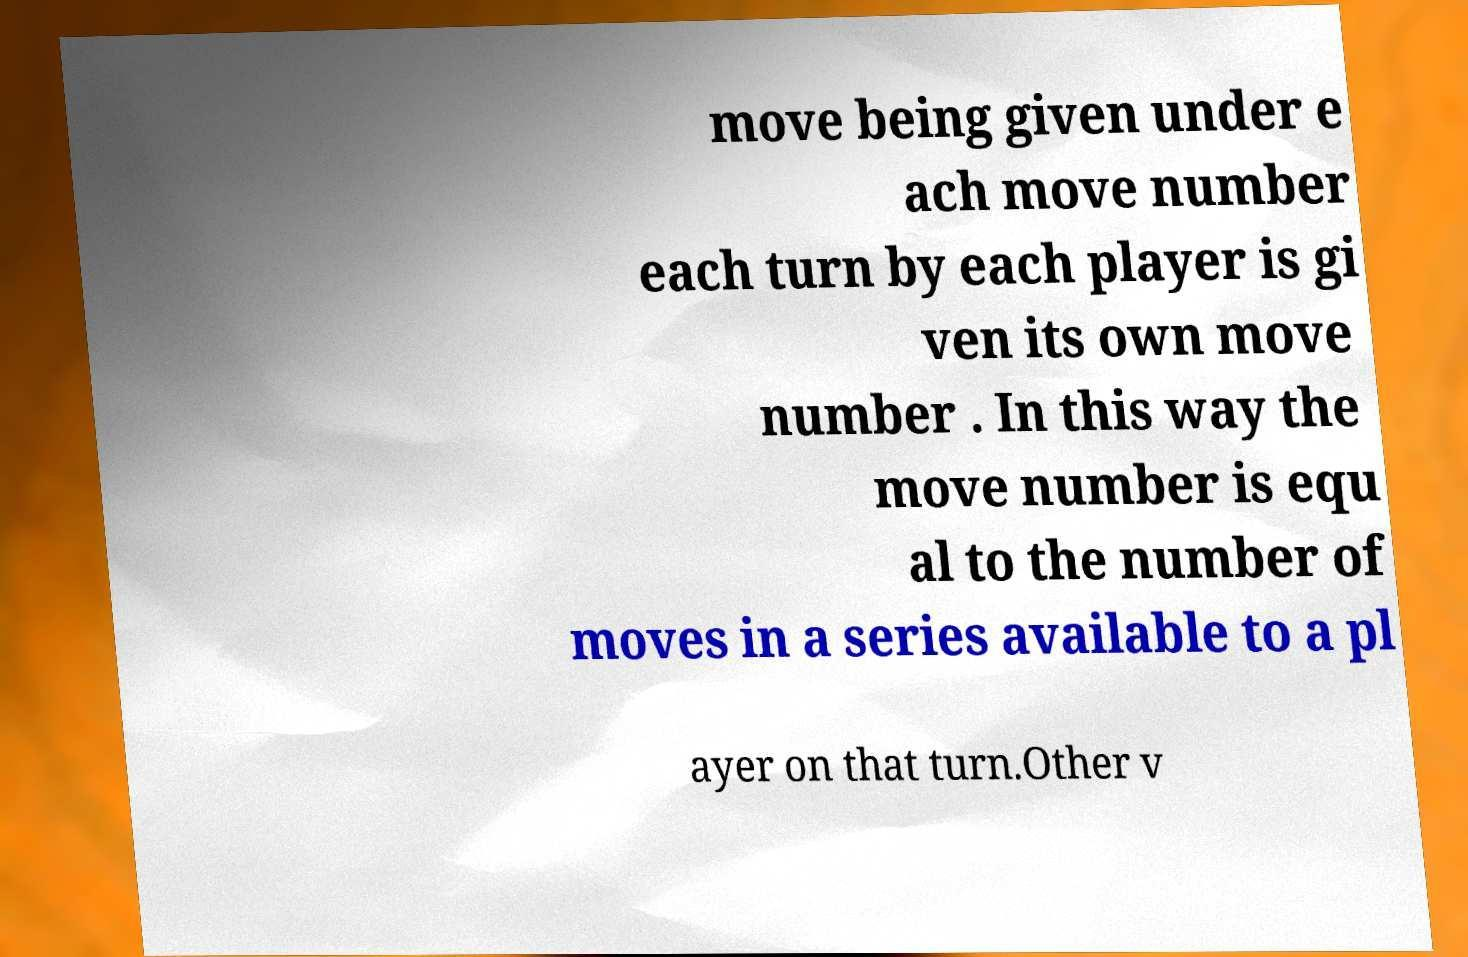Can you read and provide the text displayed in the image?This photo seems to have some interesting text. Can you extract and type it out for me? move being given under e ach move number each turn by each player is gi ven its own move number . In this way the move number is equ al to the number of moves in a series available to a pl ayer on that turn.Other v 